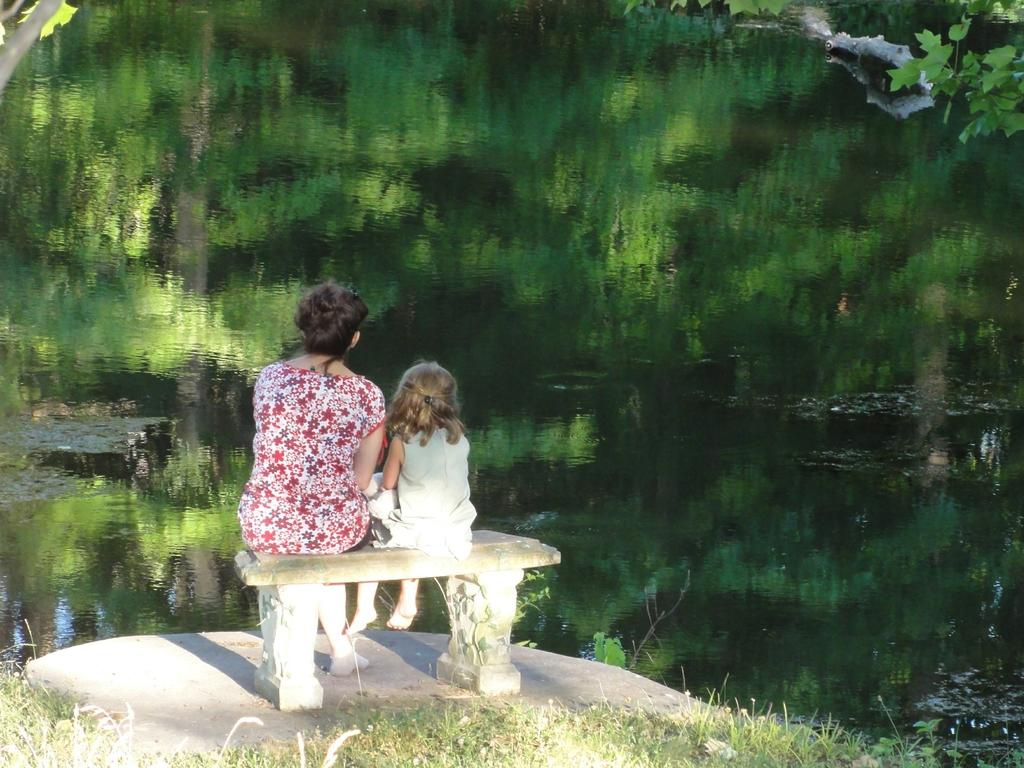Who can be seen in the image? There is a woman and a girl in the image. What are the woman and the girl doing in the image? Both the woman and the girl are sitting on a bench. What can be seen in the background of the image? There is water visible in the image, as well as a plant and grass on the ground. What type of vest is the plant wearing in the image? There is no vest present in the image, as the plant is not a person or animal. 